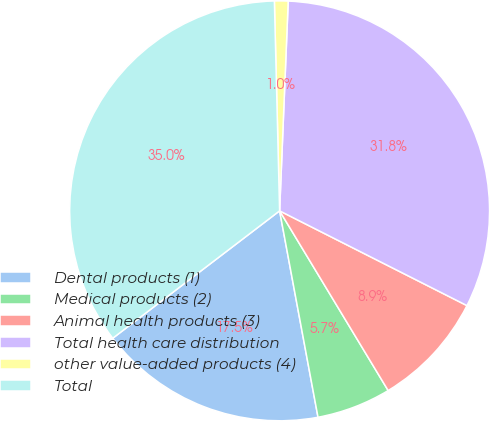<chart> <loc_0><loc_0><loc_500><loc_500><pie_chart><fcel>Dental products (1)<fcel>Medical products (2)<fcel>Animal health products (3)<fcel>Total health care distribution<fcel>other value-added products (4)<fcel>Total<nl><fcel>17.55%<fcel>5.72%<fcel>8.9%<fcel>31.8%<fcel>1.05%<fcel>34.98%<nl></chart> 